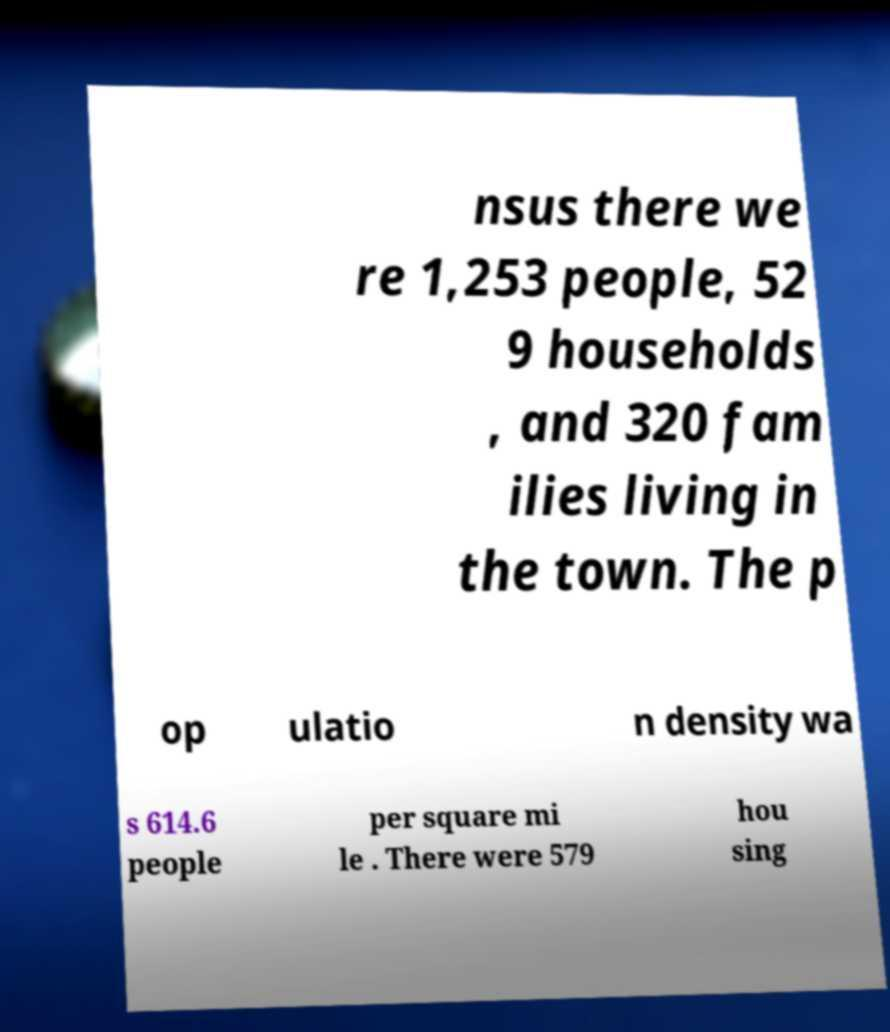What messages or text are displayed in this image? I need them in a readable, typed format. nsus there we re 1,253 people, 52 9 households , and 320 fam ilies living in the town. The p op ulatio n density wa s 614.6 people per square mi le . There were 579 hou sing 